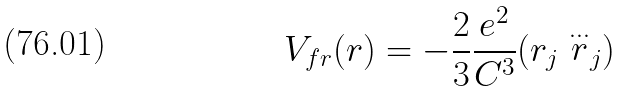<formula> <loc_0><loc_0><loc_500><loc_500>V _ { f r } ( r ) = - \frac { 2 } { 3 } \frac { e ^ { 2 } } { C ^ { 3 } } ( r _ { j } \stackrel { \dots } { r } _ { j } )</formula> 